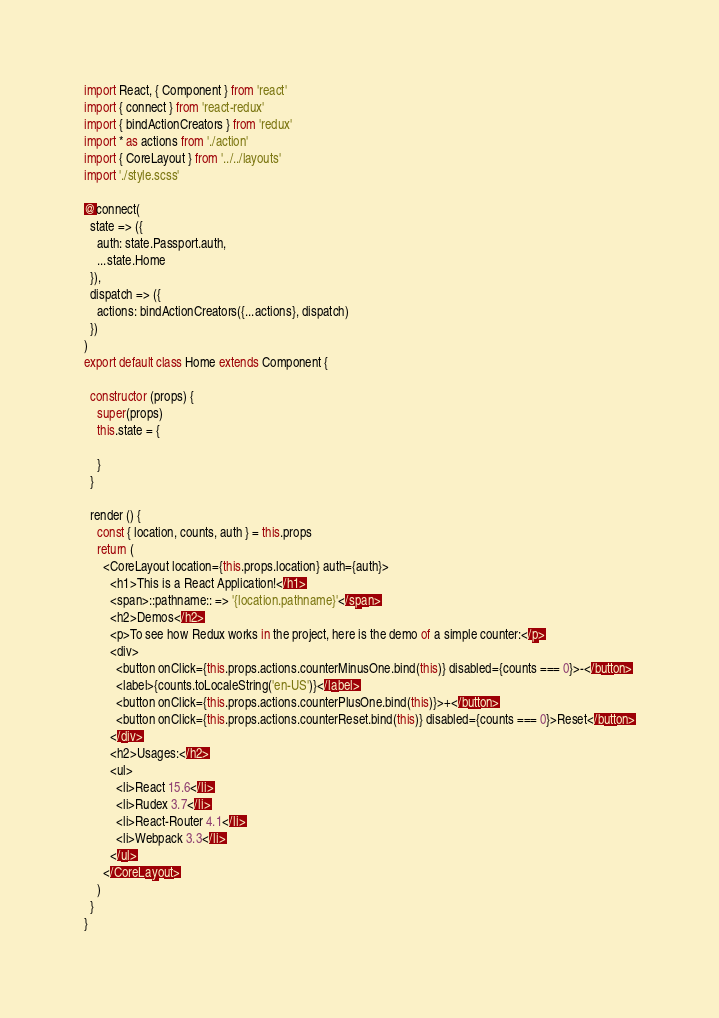Convert code to text. <code><loc_0><loc_0><loc_500><loc_500><_JavaScript_>import React, { Component } from 'react'
import { connect } from 'react-redux'
import { bindActionCreators } from 'redux'
import * as actions from './action'
import { CoreLayout } from '../../layouts'
import './style.scss'

@connect(
  state => ({
    auth: state.Passport.auth,
    ...state.Home
  }),
  dispatch => ({
    actions: bindActionCreators({...actions}, dispatch)
  })
)
export default class Home extends Component {

  constructor (props) {
    super(props)
    this.state = {

    }
  }

  render () {
    const { location, counts, auth } = this.props
    return (
      <CoreLayout location={this.props.location} auth={auth}>
        <h1>This is a React Application!</h1>
        <span>::pathname:: => '{location.pathname}'</span>
        <h2>Demos</h2>
        <p>To see how Redux works in the project, here is the demo of a simple counter:</p>
        <div>
          <button onClick={this.props.actions.counterMinusOne.bind(this)} disabled={counts === 0}>-</button>
          <label>{counts.toLocaleString('en-US')}</label>
          <button onClick={this.props.actions.counterPlusOne.bind(this)}>+</button>
          <button onClick={this.props.actions.counterReset.bind(this)} disabled={counts === 0}>Reset</button>
        </div>
        <h2>Usages:</h2>
        <ul>
          <li>React 15.6</li>
          <li>Rudex 3.7</li>
          <li>React-Router 4.1</li>
          <li>Webpack 3.3</li>
        </ul>
      </CoreLayout>
    )
  }
}</code> 